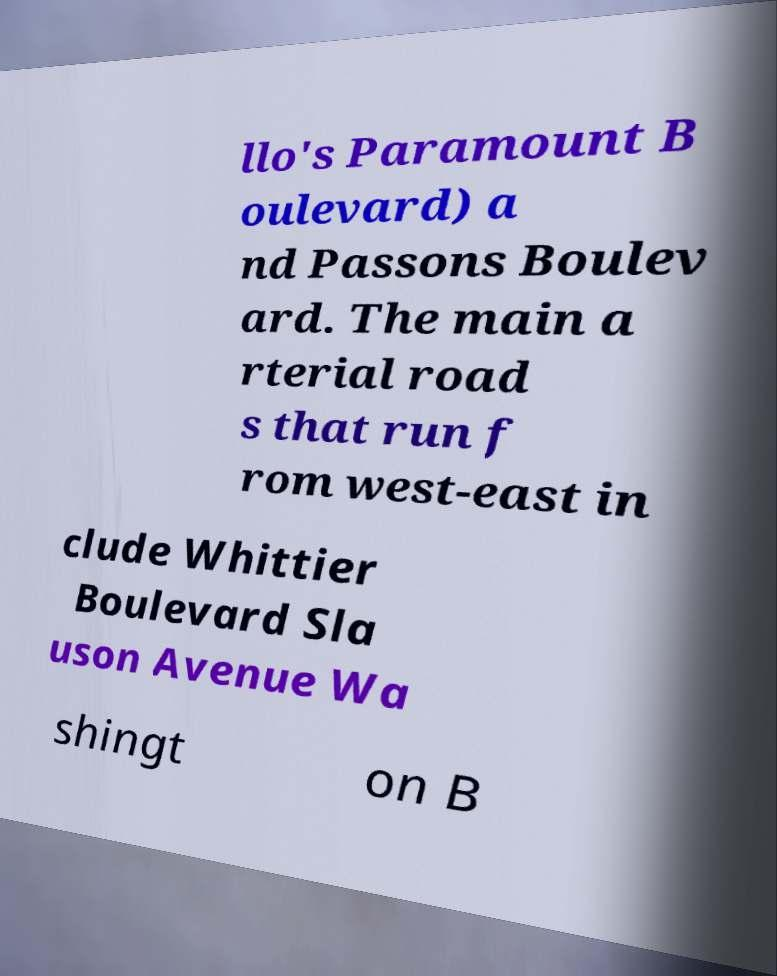There's text embedded in this image that I need extracted. Can you transcribe it verbatim? llo's Paramount B oulevard) a nd Passons Boulev ard. The main a rterial road s that run f rom west-east in clude Whittier Boulevard Sla uson Avenue Wa shingt on B 